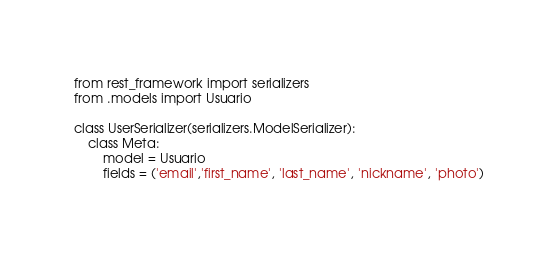<code> <loc_0><loc_0><loc_500><loc_500><_Python_>from rest_framework import serializers
from .models import Usuario

class UserSerializer(serializers.ModelSerializer):
    class Meta:
        model = Usuario
        fields = ('email','first_name', 'last_name', 'nickname', 'photo')</code> 